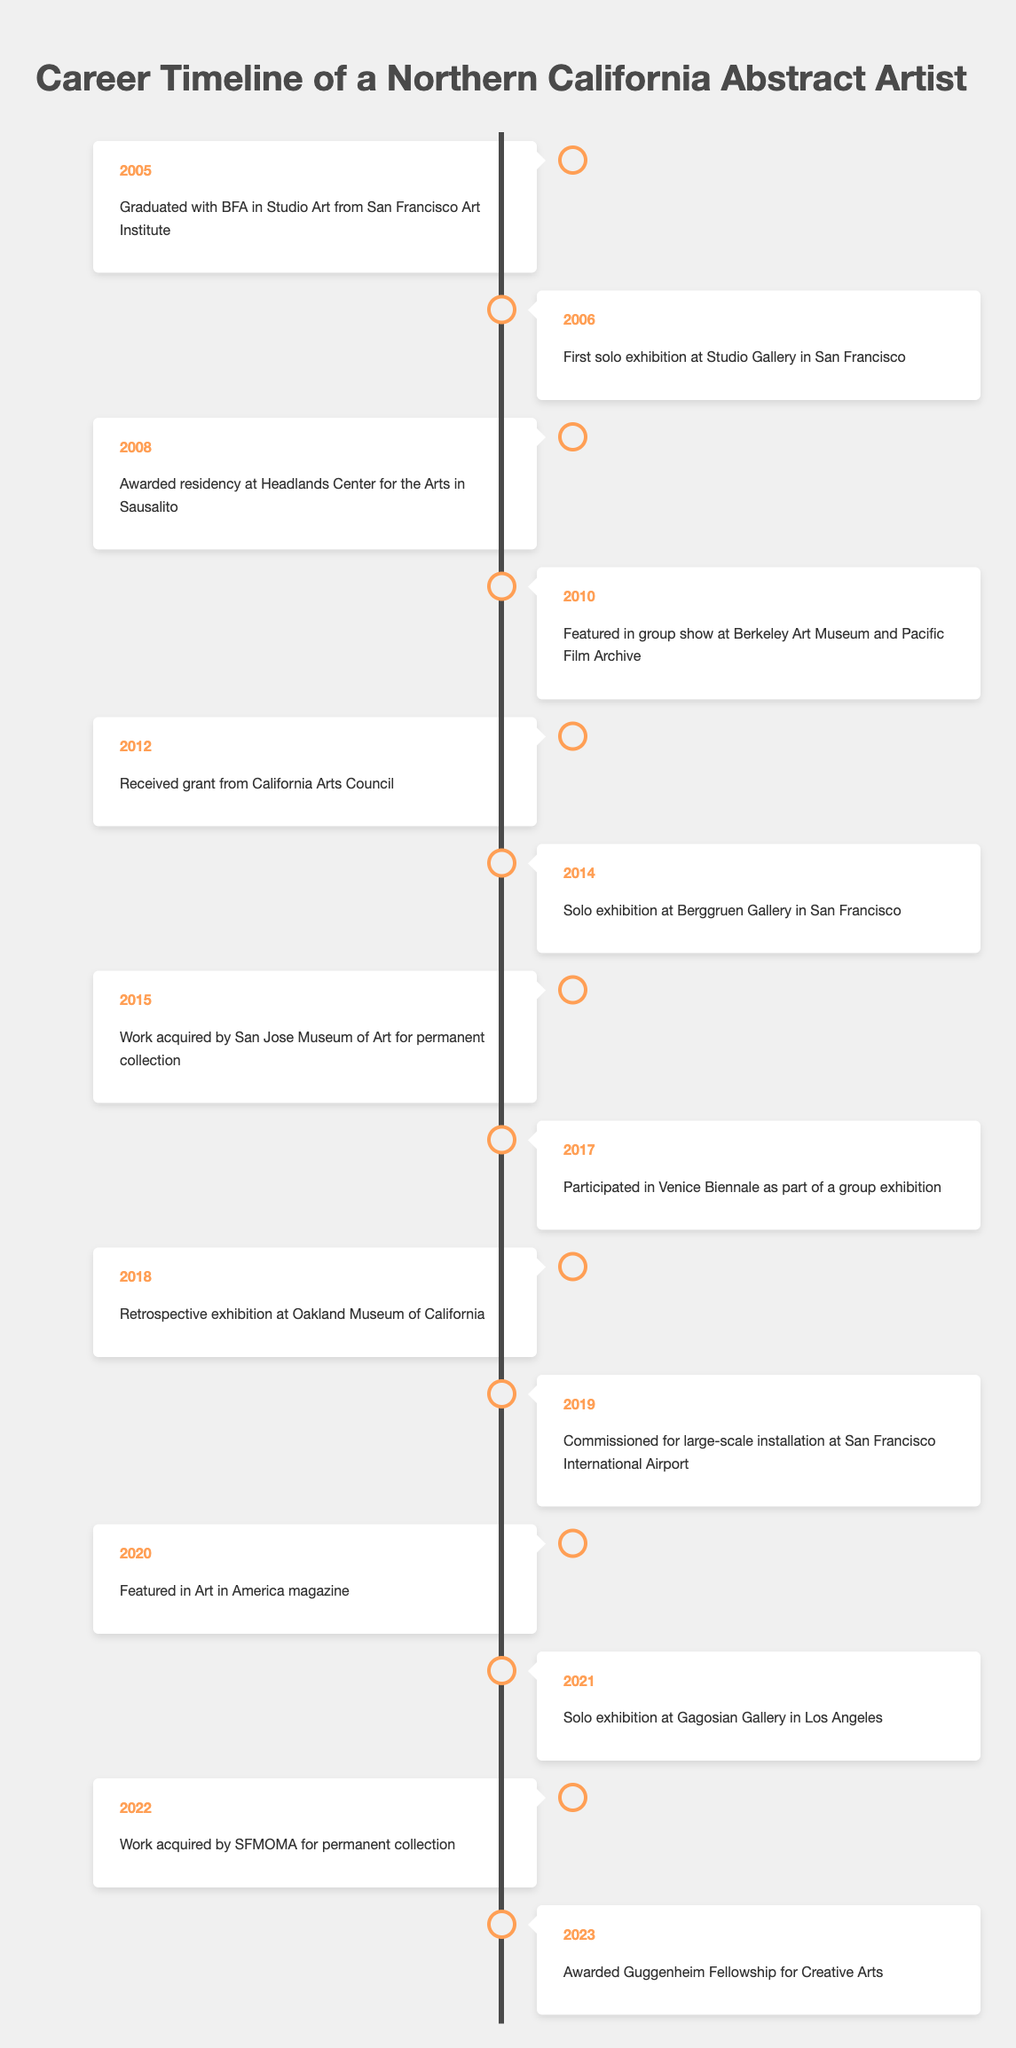What year did the artist graduate with a BFA in Studio Art? The event related to graduating with a BFA is listed in the row for the year 2005.
Answer: 2005 What significant event happened in 2021? The event in 2021 is a solo exhibition at Gagosian Gallery in Los Angeles, found in the corresponding row for that year.
Answer: Solo exhibition at Gagosian Gallery in Los Angeles How many years passed between the first solo exhibition and the retrospective exhibition? The first solo exhibition occurred in 2006 and the retrospective exhibition took place in 2018. The years between are 2018 - 2006 = 12 years.
Answer: 12 years Did the artist receive a grant from the California Arts Council? The timeline includes an event in 2012 stating that the artist received a grant from the California Arts Council, which confirms the statement as true.
Answer: Yes What is the difference in years between the first acquisition of their work by a museum and the latest acquisition? The work was acquired by the San Jose Museum of Art in 2015 and then by SFMOMA in 2022. The difference is calculated as 2022 - 2015 = 7 years.
Answer: 7 years How many solo exhibitions has the artist had by the year 2020? The artist had solo exhibitions in 2006, 2014, and 2021. Counting these gives a total of 3 solo exhibitions by 2020.
Answer: 3 exhibitions In which year did the artist participate in the Venice Biennale? According to the timeline, the artist participated in the Venice Biennale in 2017, as indicated in that year’s entry.
Answer: 2017 What percentage of the events listed involved exhibitions? There are 14 events in total, with 5 specific to solo exhibitions and 3 to group exhibitions, totaling 8 exhibitions. The percentage is (8/14) * 100 = approximately 57.14%.
Answer: Approximately 57.14% How many years elapsed from the first solo exhibition to the Guggenheim Fellowship award? The artist had their first solo exhibition in 2006 and was awarded the Guggenheim Fellowship in 2023. The elapsed time is 2023 - 2006 = 17 years.
Answer: 17 years 